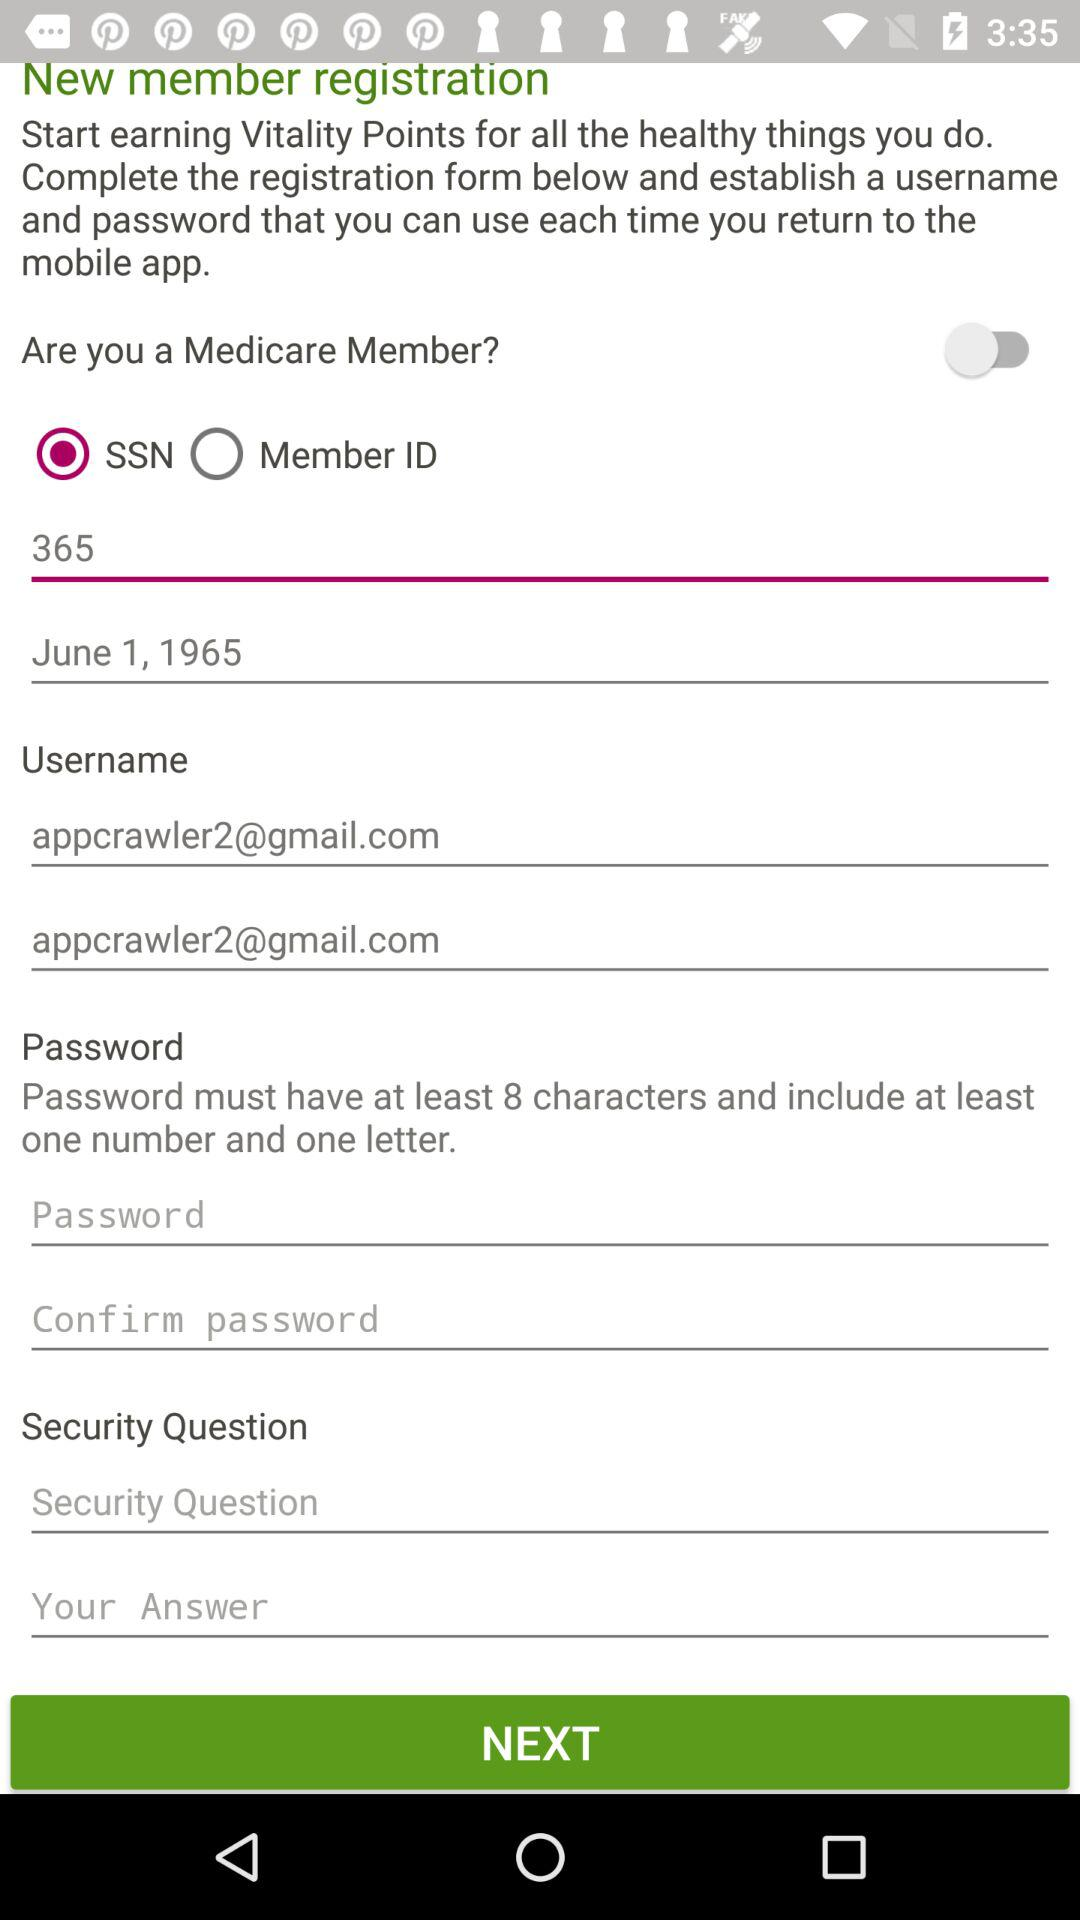What is the status of "Are you a Medicare Member?"? The status is "off". 